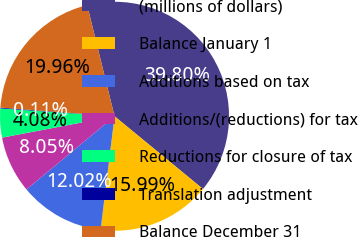Convert chart. <chart><loc_0><loc_0><loc_500><loc_500><pie_chart><fcel>(millions of dollars)<fcel>Balance January 1<fcel>Additions based on tax<fcel>Additions/(reductions) for tax<fcel>Reductions for closure of tax<fcel>Translation adjustment<fcel>Balance December 31<nl><fcel>39.8%<fcel>15.99%<fcel>12.02%<fcel>8.05%<fcel>4.08%<fcel>0.11%<fcel>19.96%<nl></chart> 